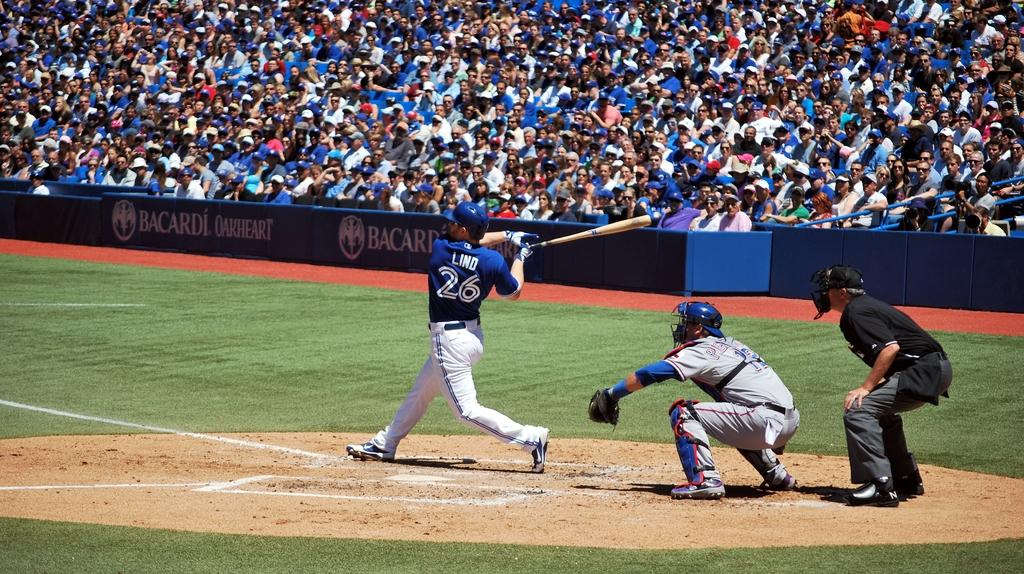<image>
Render a clear and concise summary of the photo. Player number 26 has just swung his bat at the baseball. 